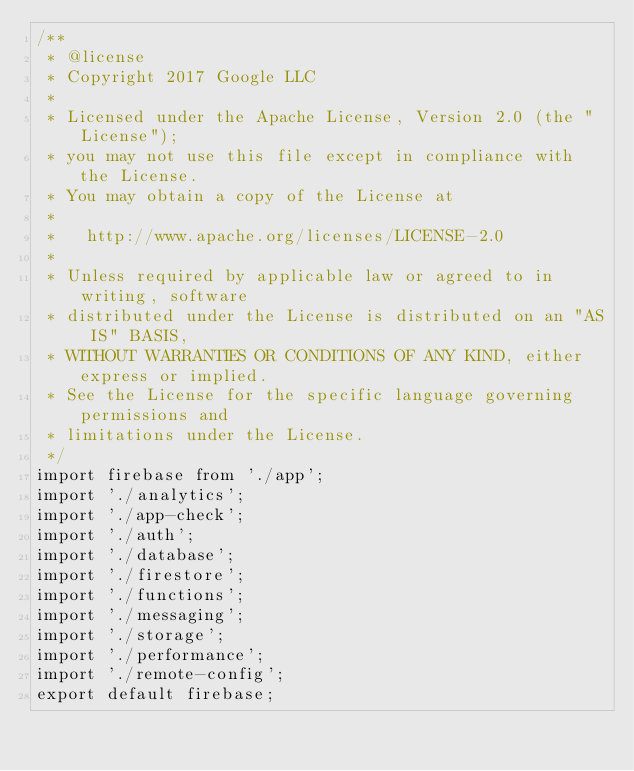<code> <loc_0><loc_0><loc_500><loc_500><_TypeScript_>/**
 * @license
 * Copyright 2017 Google LLC
 *
 * Licensed under the Apache License, Version 2.0 (the "License");
 * you may not use this file except in compliance with the License.
 * You may obtain a copy of the License at
 *
 *   http://www.apache.org/licenses/LICENSE-2.0
 *
 * Unless required by applicable law or agreed to in writing, software
 * distributed under the License is distributed on an "AS IS" BASIS,
 * WITHOUT WARRANTIES OR CONDITIONS OF ANY KIND, either express or implied.
 * See the License for the specific language governing permissions and
 * limitations under the License.
 */
import firebase from './app';
import './analytics';
import './app-check';
import './auth';
import './database';
import './firestore';
import './functions';
import './messaging';
import './storage';
import './performance';
import './remote-config';
export default firebase;
</code> 